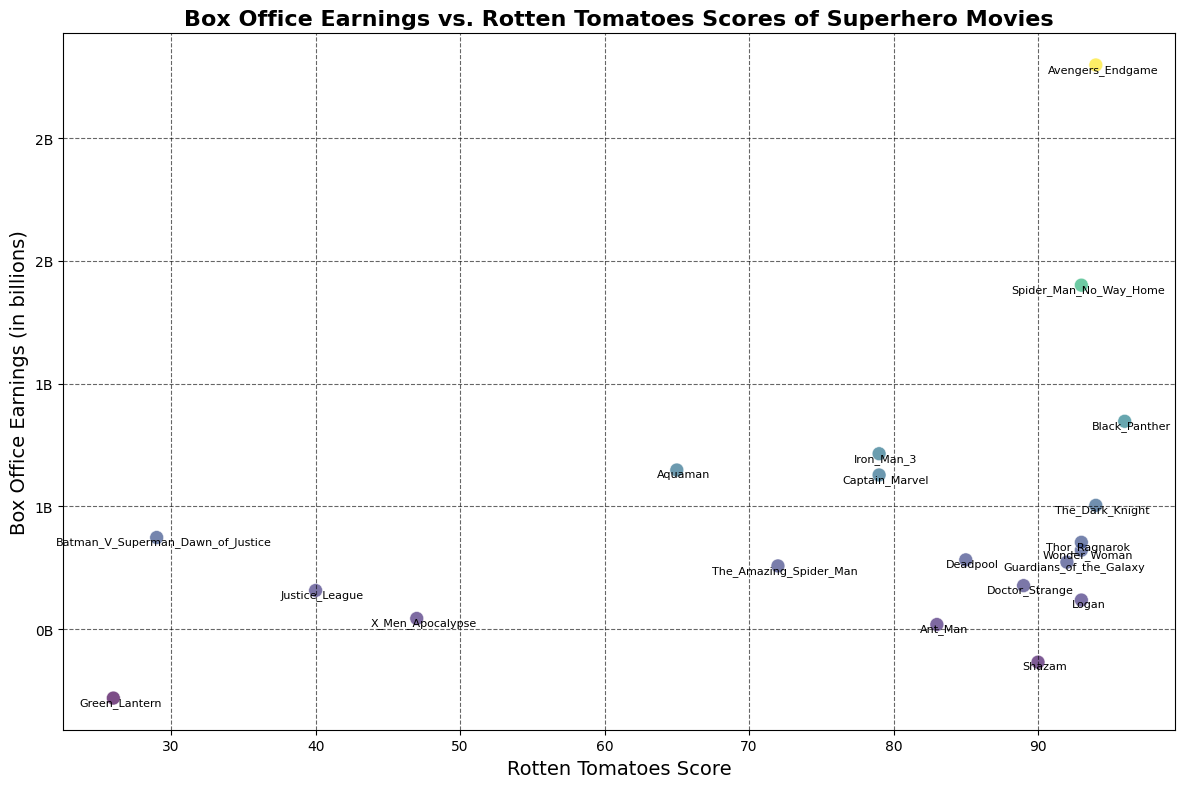what is the box office earning and Rotten Tomatoes score for the highest-grossing superhero movie on the plot? The highest-grossing superhero movie on the plot is "Avengers Endgame" which has the highest point on the earnings axis. By checking the plot, we can see that "Avengers Endgame" has a Box Office earning of approximately 2.8 billion and a Rotten Tomatoes score of 94.
Answer: 2.8 billion, 94 Which movie has the lowest box office earnings and what is its Rotten Tomatoes score? By identifying the lowest point on the earnings axis, the movie with the lowest box office earnings is "Green Lantern". Its box office earnings are approximately 219.85 million and the Rotten Tomatoes score is 26.
Answer: Green Lantern, 26 Which movies have a Rotten Tomatoes score greater than 90 and what are their box office earnings? By looking at the movies positioned above 90 on the Rotten Tomatoes' axis, we find: "Avengers Endgame" with approximately 2.8 billion, "Black Panther" with approximately 1.35 billion, "Spider-Man No Way Home" with approximately 1.9 billion, "Wonder Woman" with approximately 821.85 million, "Guardians of the Galaxy" with approximately 773.35 million, "Thor Ragnarok" with approximately 854.06 million, "Logan" with approximately 619.02 million, and "Shazam" with approximately 366.08 million.
Answer: Several movies with earnings: Avenger Endgame, Black Panther, Spider-Man No Way Home, Wonder Woman, Guardians of the Galaxy, Thor Ragnarok, Logan, Shazam What is the average box office earnings of movies with a Rotten Tomatoes score below 50? To find the average box office earnings of movies with a Rotten Tomatoes score below 50, we need to identify those movies: "Batman v Superman Dawn of Justice" (873.63M), "Justice League" (657.92M), "X-Men Apocalypse" (543.93M), and "Green Lantern" (219.85M). The sum of their earnings is approximately 2.3 billion. Dividing by the 4 movies, the average is approximately 575.83 million.
Answer: 575.83 million How many movies have box office earnings of more than 1 billion and what are their Rotten Tomatoes scores? By identifying points on the plot with box office earnings greater than 1 billion, we find: "Avengers Endgame" (94), "Black Panther" (96), "Iron Man 3" (79), "Spider-Man No Way Home" (93), "The Dark Knight" (94), and "Captain Marvel" (79). These are six movies.
Answer: Six movies: Avengers Endgame (94), Black Panther (96), Iron Man 3 (79), Spider-Man No Way Home (93), The Dark Knight (94), Captain Marvel (79) Which movie has a higher Rotten Tomatoes score, "Aquaman" or "Doctor Strange"? By comparing the positions on the plot for "Aquaman" and "Doctor Strange", we see that "Doctor Strange" has a higher Rotten Tomatoes score of 89 compared to "Aquaman" which has a score of 65.
Answer: Doctor Strange Which movie has the most significant gap between high Box Office earnings and low Rotten Tomatoes score? The movie with the significant gap between high box office earnings and low Rotten Tomatoes score is "Batman v Superman Dawn of Justice" which has approximately 873.63 million box office earnings and a very low Rotten Tomatoes score of 29.
Answer: Batman v Superman Dawn of Justice 